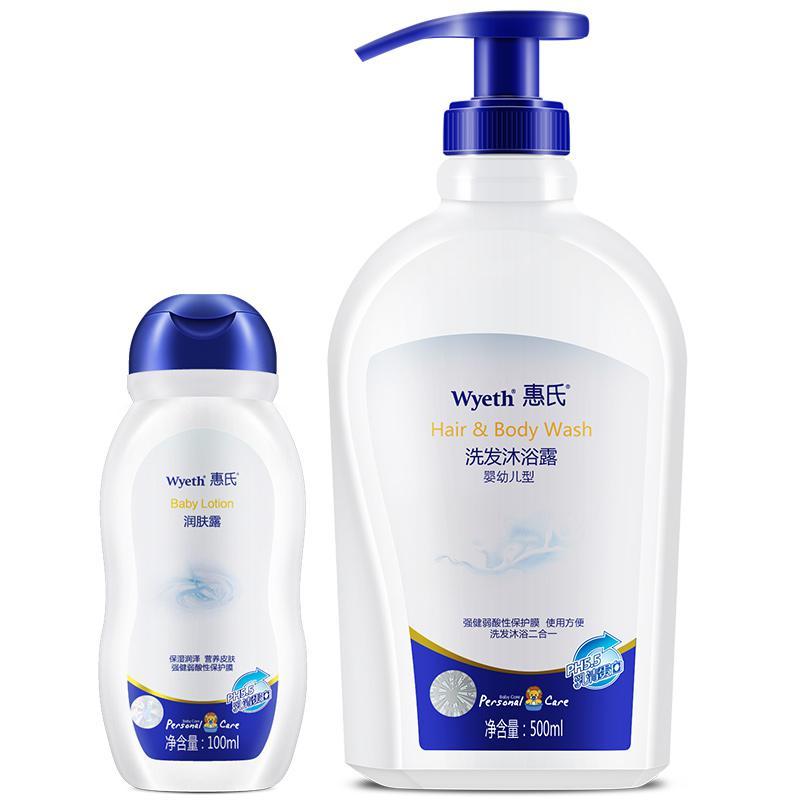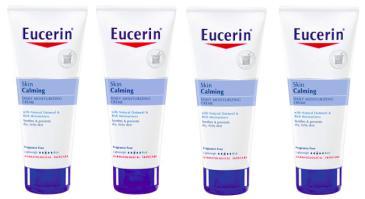The first image is the image on the left, the second image is the image on the right. Examine the images to the left and right. Is the description "We see three packages of lotion." accurate? Answer yes or no. No. 